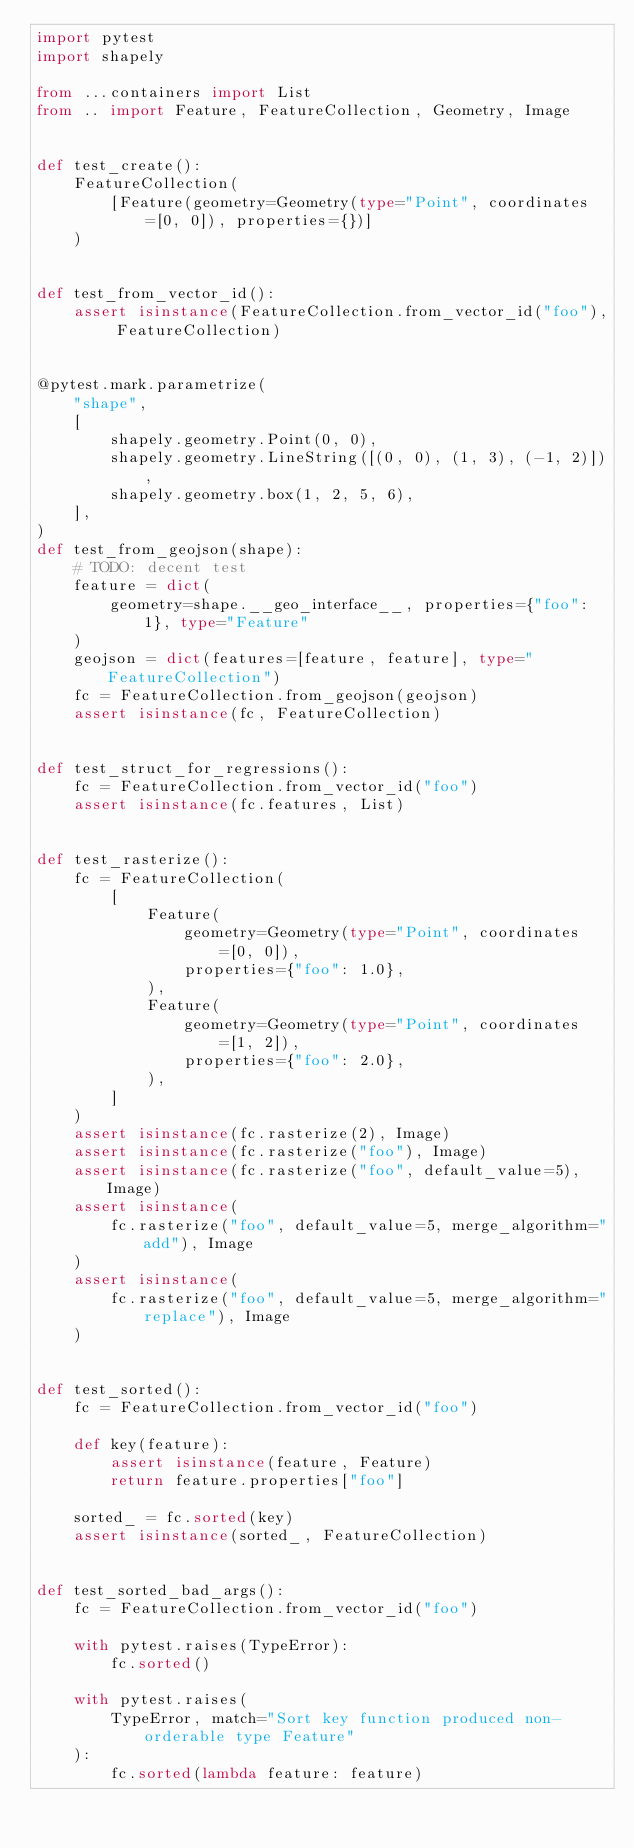<code> <loc_0><loc_0><loc_500><loc_500><_Python_>import pytest
import shapely

from ...containers import List
from .. import Feature, FeatureCollection, Geometry, Image


def test_create():
    FeatureCollection(
        [Feature(geometry=Geometry(type="Point", coordinates=[0, 0]), properties={})]
    )


def test_from_vector_id():
    assert isinstance(FeatureCollection.from_vector_id("foo"), FeatureCollection)


@pytest.mark.parametrize(
    "shape",
    [
        shapely.geometry.Point(0, 0),
        shapely.geometry.LineString([(0, 0), (1, 3), (-1, 2)]),
        shapely.geometry.box(1, 2, 5, 6),
    ],
)
def test_from_geojson(shape):
    # TODO: decent test
    feature = dict(
        geometry=shape.__geo_interface__, properties={"foo": 1}, type="Feature"
    )
    geojson = dict(features=[feature, feature], type="FeatureCollection")
    fc = FeatureCollection.from_geojson(geojson)
    assert isinstance(fc, FeatureCollection)


def test_struct_for_regressions():
    fc = FeatureCollection.from_vector_id("foo")
    assert isinstance(fc.features, List)


def test_rasterize():
    fc = FeatureCollection(
        [
            Feature(
                geometry=Geometry(type="Point", coordinates=[0, 0]),
                properties={"foo": 1.0},
            ),
            Feature(
                geometry=Geometry(type="Point", coordinates=[1, 2]),
                properties={"foo": 2.0},
            ),
        ]
    )
    assert isinstance(fc.rasterize(2), Image)
    assert isinstance(fc.rasterize("foo"), Image)
    assert isinstance(fc.rasterize("foo", default_value=5), Image)
    assert isinstance(
        fc.rasterize("foo", default_value=5, merge_algorithm="add"), Image
    )
    assert isinstance(
        fc.rasterize("foo", default_value=5, merge_algorithm="replace"), Image
    )


def test_sorted():
    fc = FeatureCollection.from_vector_id("foo")

    def key(feature):
        assert isinstance(feature, Feature)
        return feature.properties["foo"]

    sorted_ = fc.sorted(key)
    assert isinstance(sorted_, FeatureCollection)


def test_sorted_bad_args():
    fc = FeatureCollection.from_vector_id("foo")

    with pytest.raises(TypeError):
        fc.sorted()

    with pytest.raises(
        TypeError, match="Sort key function produced non-orderable type Feature"
    ):
        fc.sorted(lambda feature: feature)
</code> 